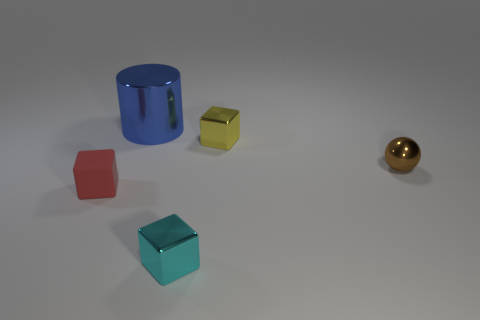Add 2 small red rubber blocks. How many objects exist? 7 Subtract all spheres. How many objects are left? 4 Add 1 tiny brown metal spheres. How many tiny brown metal spheres are left? 2 Add 2 cyan metallic objects. How many cyan metallic objects exist? 3 Subtract 0 gray cubes. How many objects are left? 5 Subtract all brown metal spheres. Subtract all large gray metal cylinders. How many objects are left? 4 